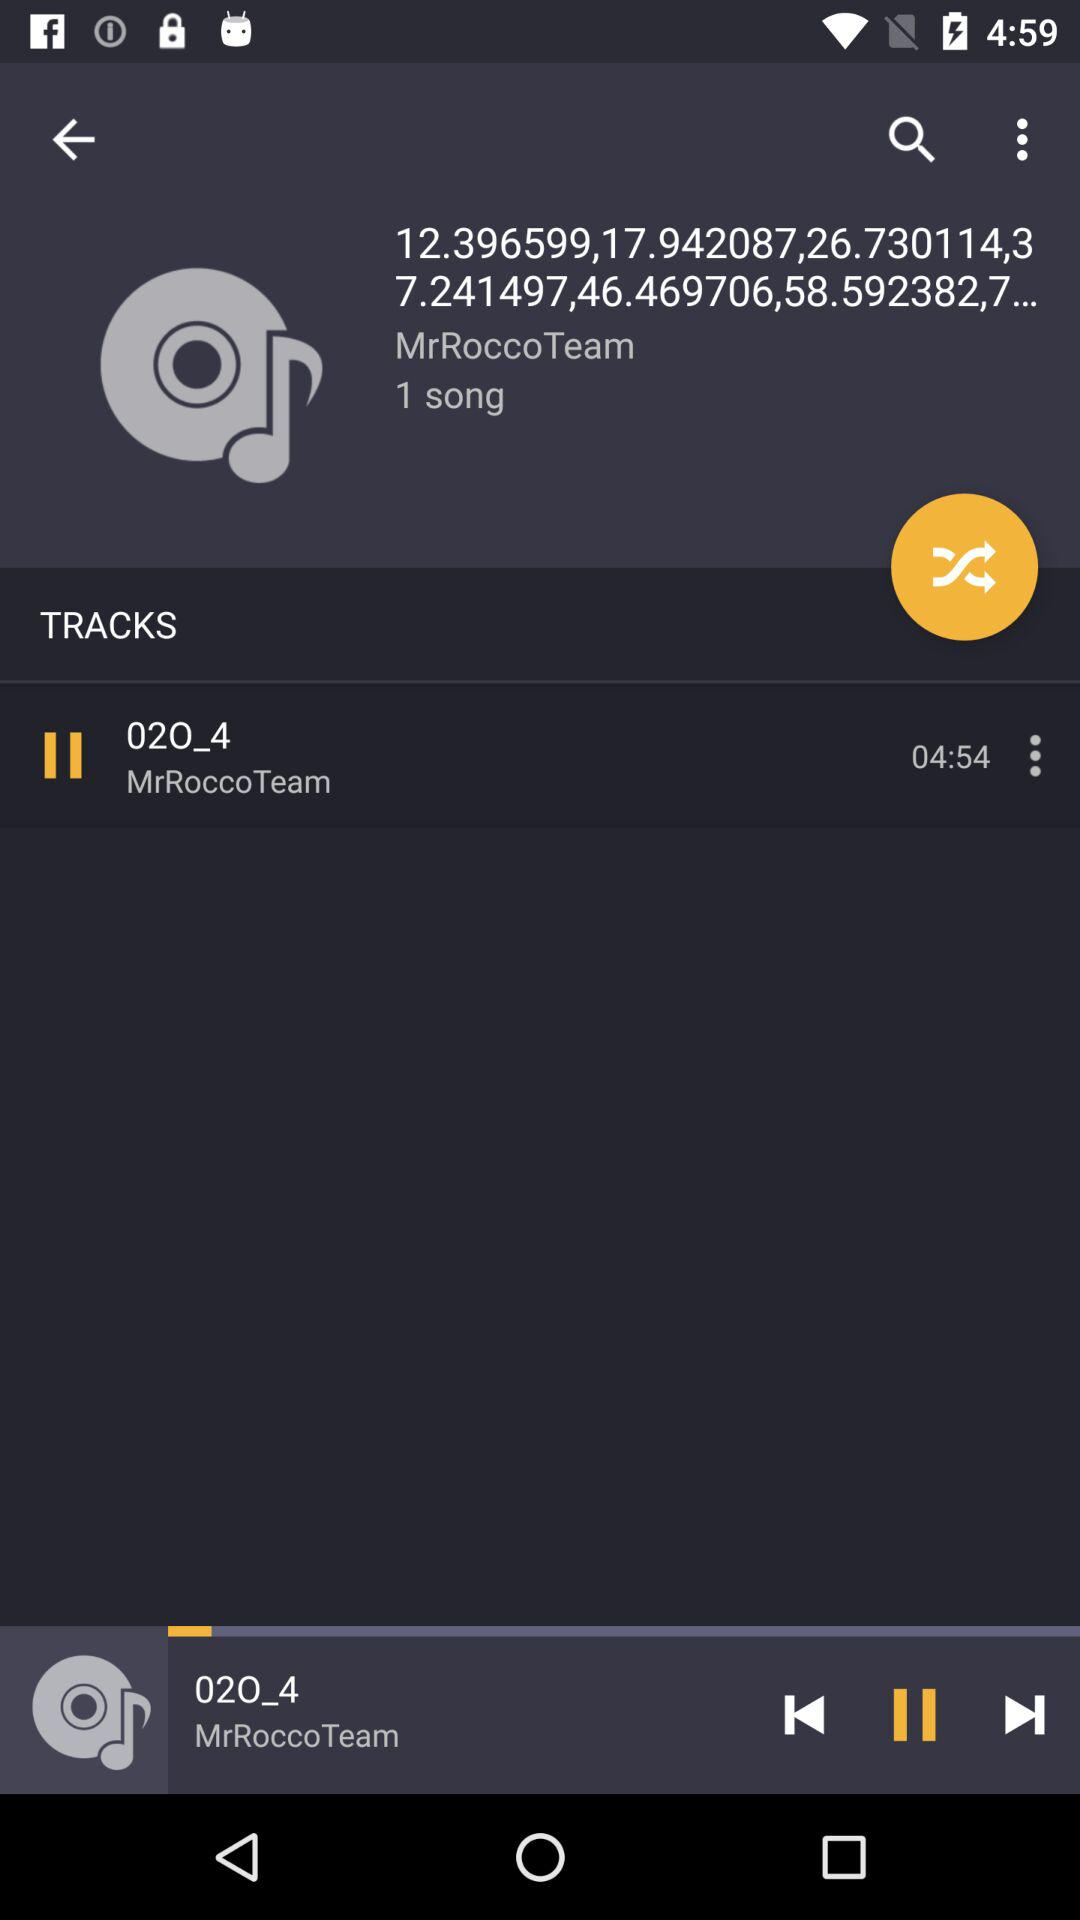What is the title of the song? The title of the song is "02O_4". 